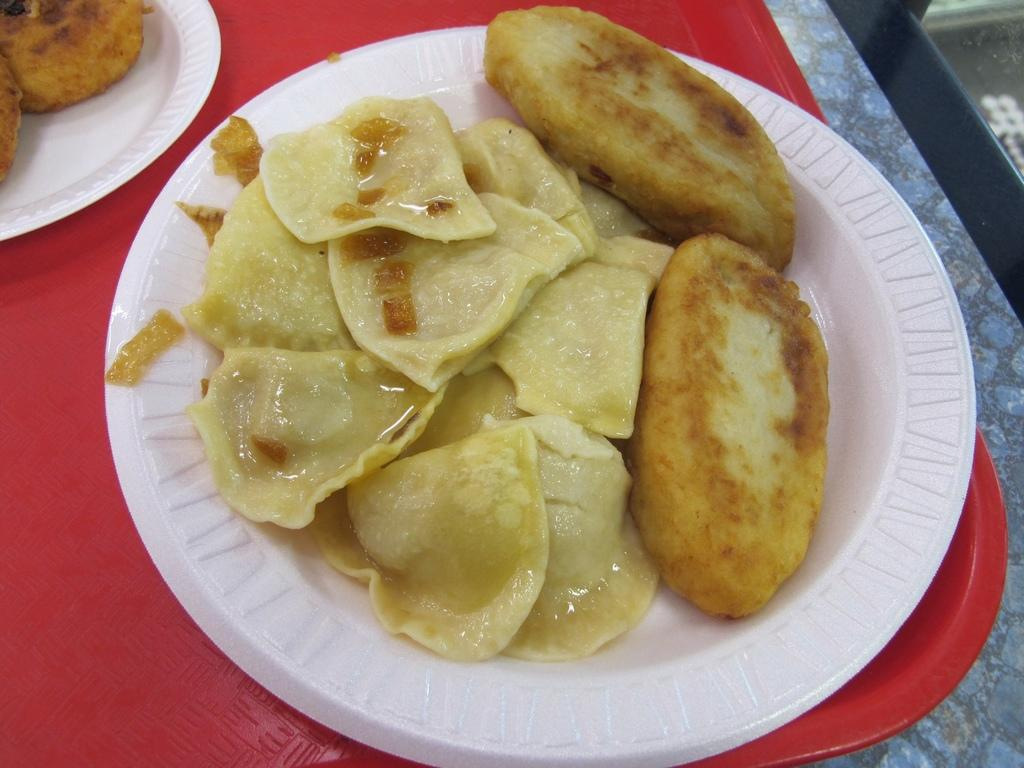What can be seen in the image related to food? There are food places in the image. Are there any more food places visible in the image? Yes, there are additional food places on the right side of the image. What is the color of the surface on which the food places are placed? The food places are placed on a red surface. What type of degree is required to work at the food places in the image? There is no information about degrees or qualifications required to work at the food places in the image. 